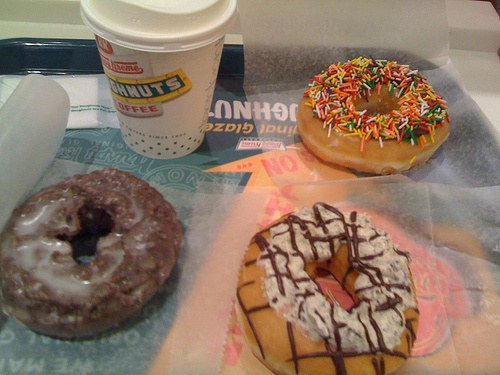Describe the objects in this image and their specific colors. I can see donut in olive, maroon, brown, gray, and tan tones, donut in olive, gray, maroon, and black tones, cup in olive, gray, and darkgray tones, and donut in olive, red, maroon, gray, and brown tones in this image. 